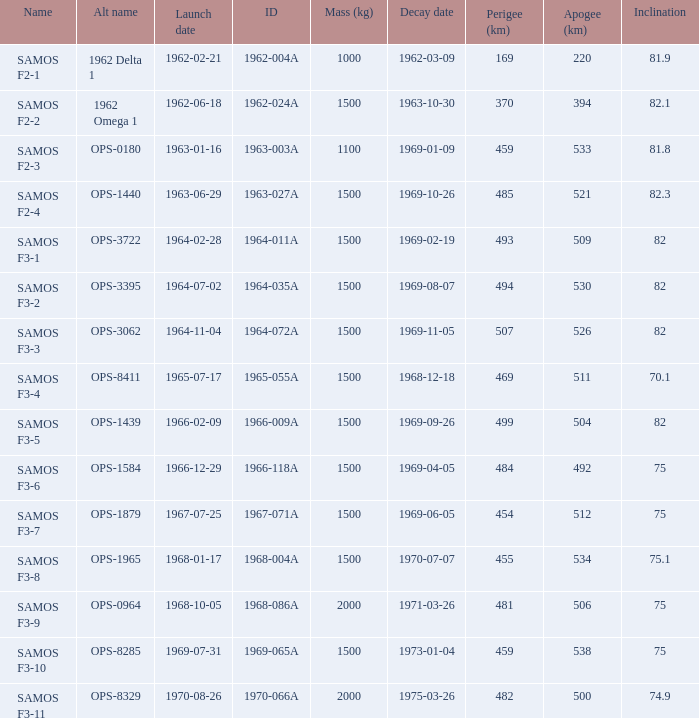What was the greatest perigee on 1969-01-09? 459.0. 